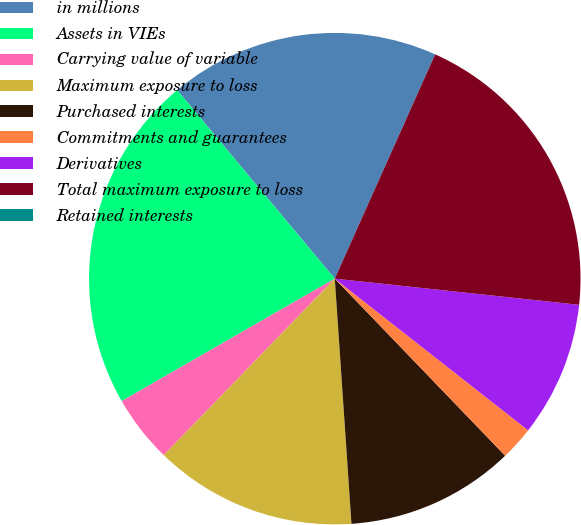Convert chart. <chart><loc_0><loc_0><loc_500><loc_500><pie_chart><fcel>in millions<fcel>Assets in VIEs<fcel>Carrying value of variable<fcel>Maximum exposure to loss<fcel>Purchased interests<fcel>Commitments and guarantees<fcel>Derivatives<fcel>Total maximum exposure to loss<fcel>Retained interests<nl><fcel>17.78%<fcel>22.22%<fcel>4.45%<fcel>13.33%<fcel>11.11%<fcel>2.22%<fcel>8.89%<fcel>20.0%<fcel>0.0%<nl></chart> 